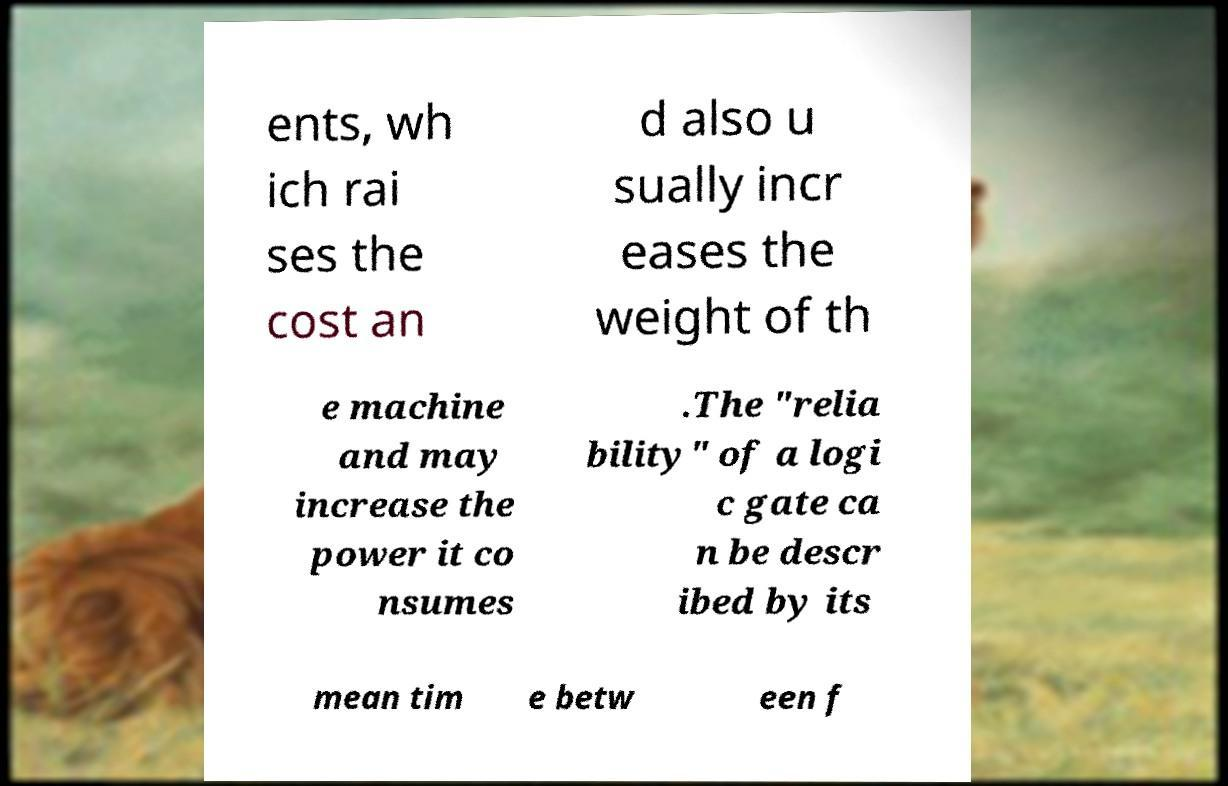Could you assist in decoding the text presented in this image and type it out clearly? ents, wh ich rai ses the cost an d also u sually incr eases the weight of th e machine and may increase the power it co nsumes .The "relia bility" of a logi c gate ca n be descr ibed by its mean tim e betw een f 